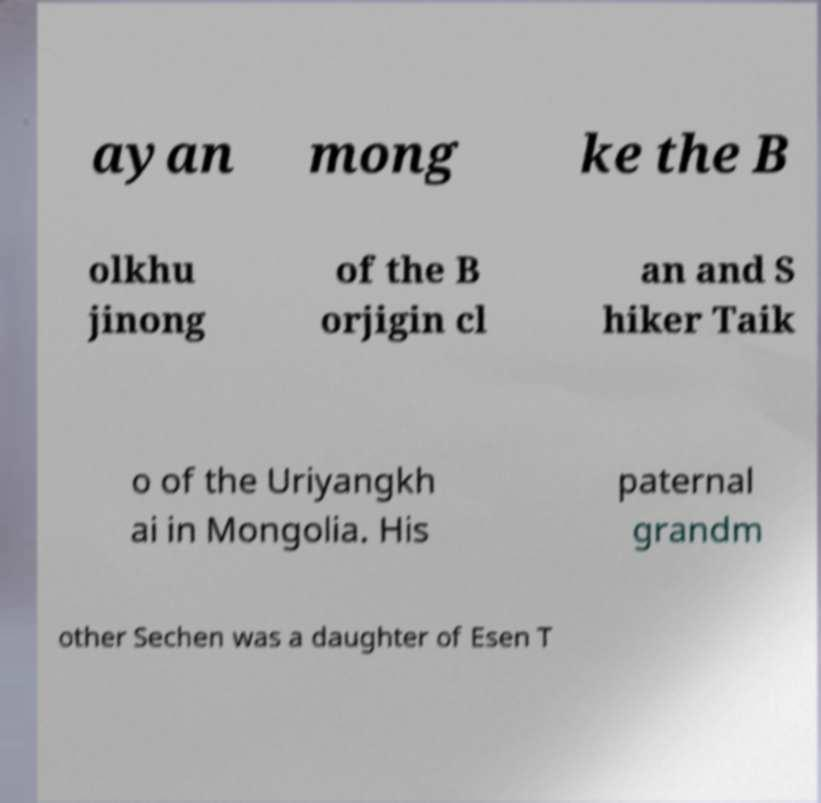Can you read and provide the text displayed in the image?This photo seems to have some interesting text. Can you extract and type it out for me? ayan mong ke the B olkhu jinong of the B orjigin cl an and S hiker Taik o of the Uriyangkh ai in Mongolia. His paternal grandm other Sechen was a daughter of Esen T 